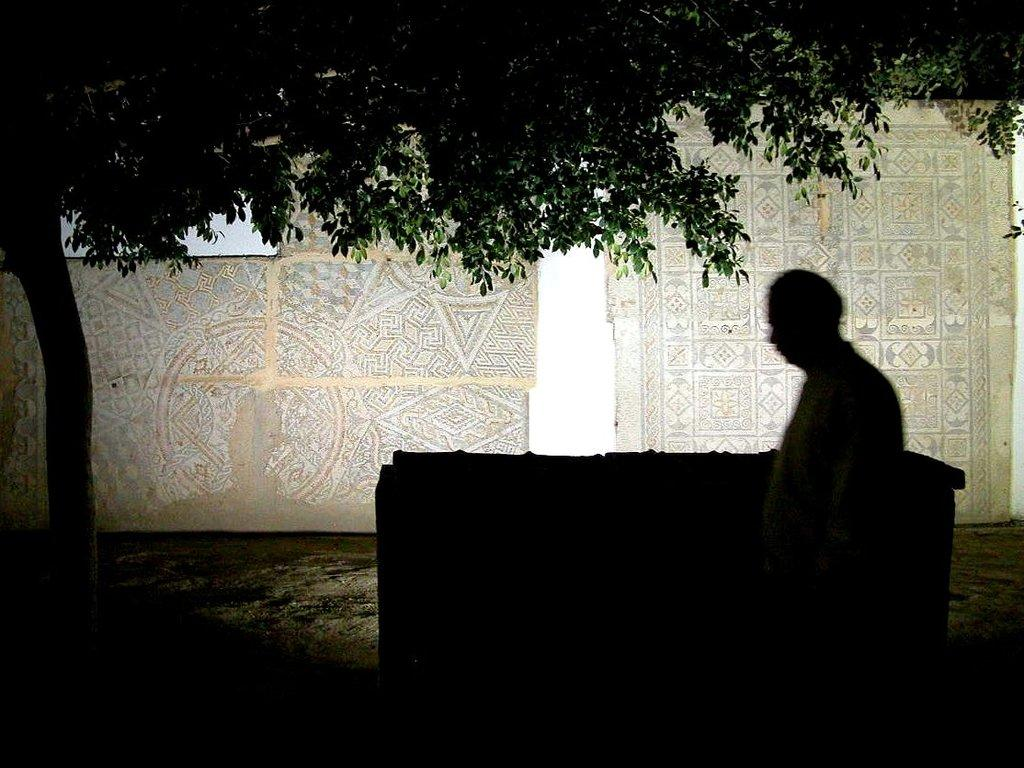What is the main subject of the image? There is a person standing in the image. What can be seen in the background of the image? There is an object and a tree visible in the background of the image. What else is present in the background of the image? There is a wall in the background of the image. What is the price of the pizzas in the image? There are no pizzas present in the image, so it is not possible to determine their price. 